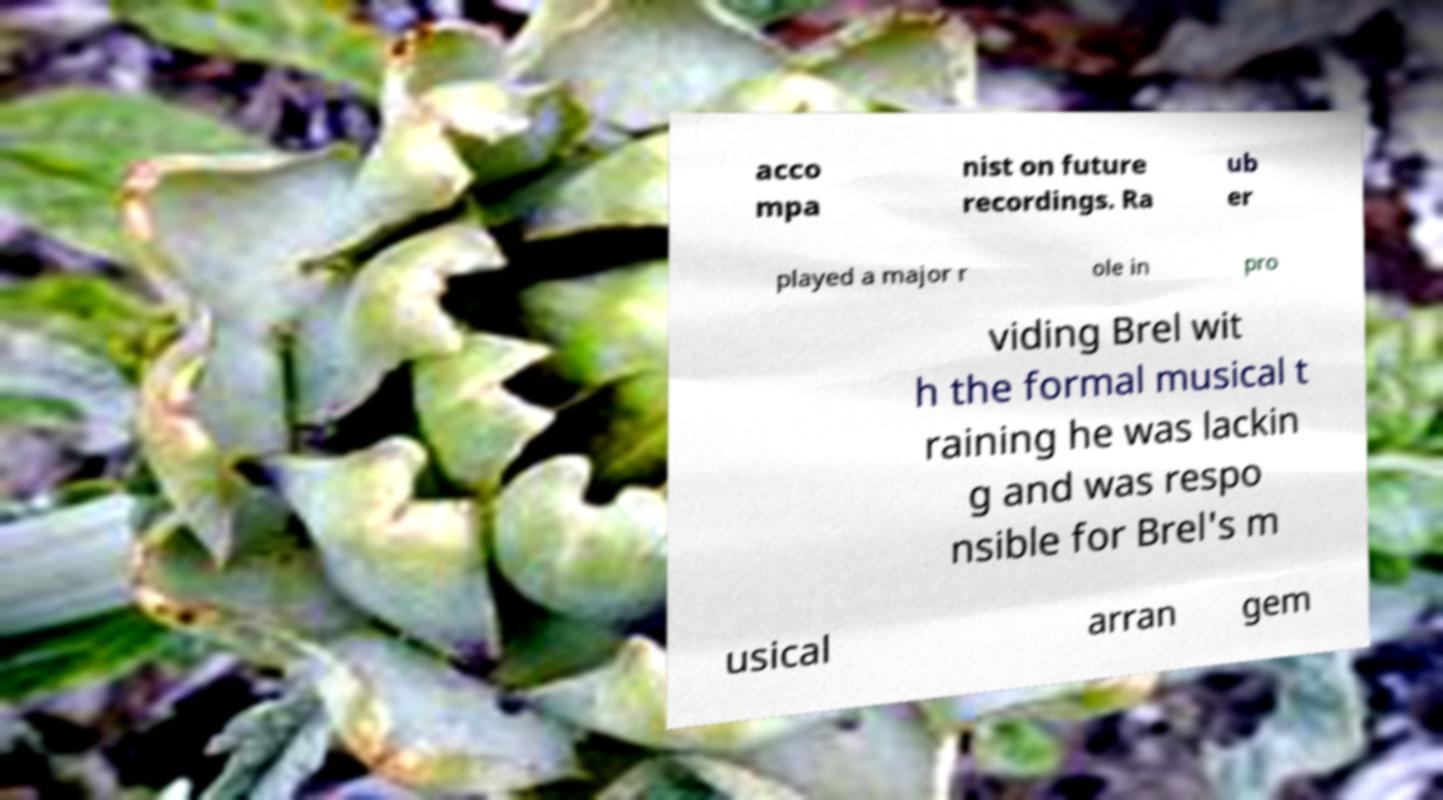Please identify and transcribe the text found in this image. acco mpa nist on future recordings. Ra ub er played a major r ole in pro viding Brel wit h the formal musical t raining he was lackin g and was respo nsible for Brel's m usical arran gem 